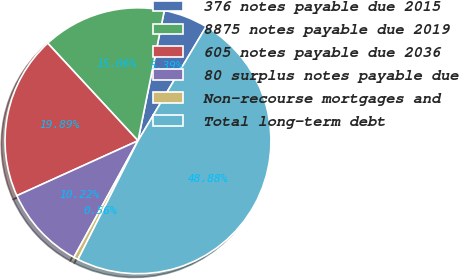<chart> <loc_0><loc_0><loc_500><loc_500><pie_chart><fcel>376 notes payable due 2015<fcel>8875 notes payable due 2019<fcel>605 notes payable due 2036<fcel>80 surplus notes payable due<fcel>Non-recourse mortgages and<fcel>Total long-term debt<nl><fcel>5.39%<fcel>15.06%<fcel>19.89%<fcel>10.22%<fcel>0.56%<fcel>48.88%<nl></chart> 